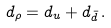<formula> <loc_0><loc_0><loc_500><loc_500>d _ { \rho } = d _ { u } + d _ { \bar { d } } \, .</formula> 